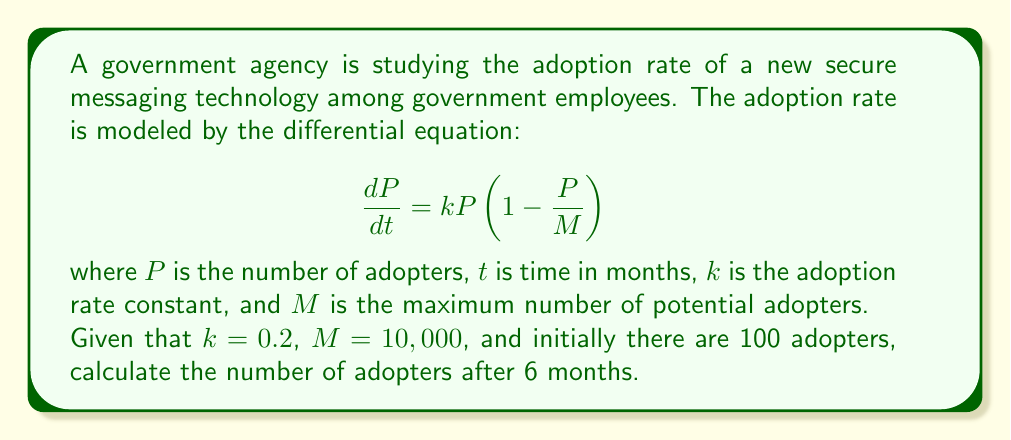Help me with this question. To solve this problem, we need to use the logistic growth model, which is a first-order differential equation. The given equation is in the standard form of the logistic growth model.

1. First, we need to solve the differential equation. The solution to the logistic growth equation is:

   $$P(t) = \frac{M}{1 + (\frac{M}{P_0} - 1)e^{-kt}}$$

   where $P_0$ is the initial number of adopters.

2. We are given the following values:
   - $k = 0.2$ (adoption rate constant)
   - $M = 10,000$ (maximum number of potential adopters)
   - $P_0 = 100$ (initial number of adopters)
   - $t = 6$ (time in months)

3. Let's substitute these values into the equation:

   $$P(6) = \frac{10,000}{1 + (\frac{10,000}{100} - 1)e^{-0.2 \cdot 6}}$$

4. Simplify:
   $$P(6) = \frac{10,000}{1 + 99e^{-1.2}}$$

5. Calculate $e^{-1.2}$:
   $$e^{-1.2} \approx 0.301194$$

6. Substitute this value:
   $$P(6) = \frac{10,000}{1 + 99 \cdot 0.301194} = \frac{10,000}{30.818206}$$

7. Calculate the final result:
   $$P(6) \approx 324.48$$

8. Since we're dealing with people, we round to the nearest whole number.
Answer: After 6 months, there will be approximately 324 adopters of the new secure messaging technology. 